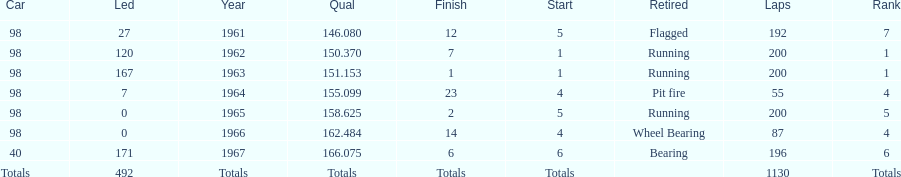How many consecutive years did parnelli place in the top 5? 5. 